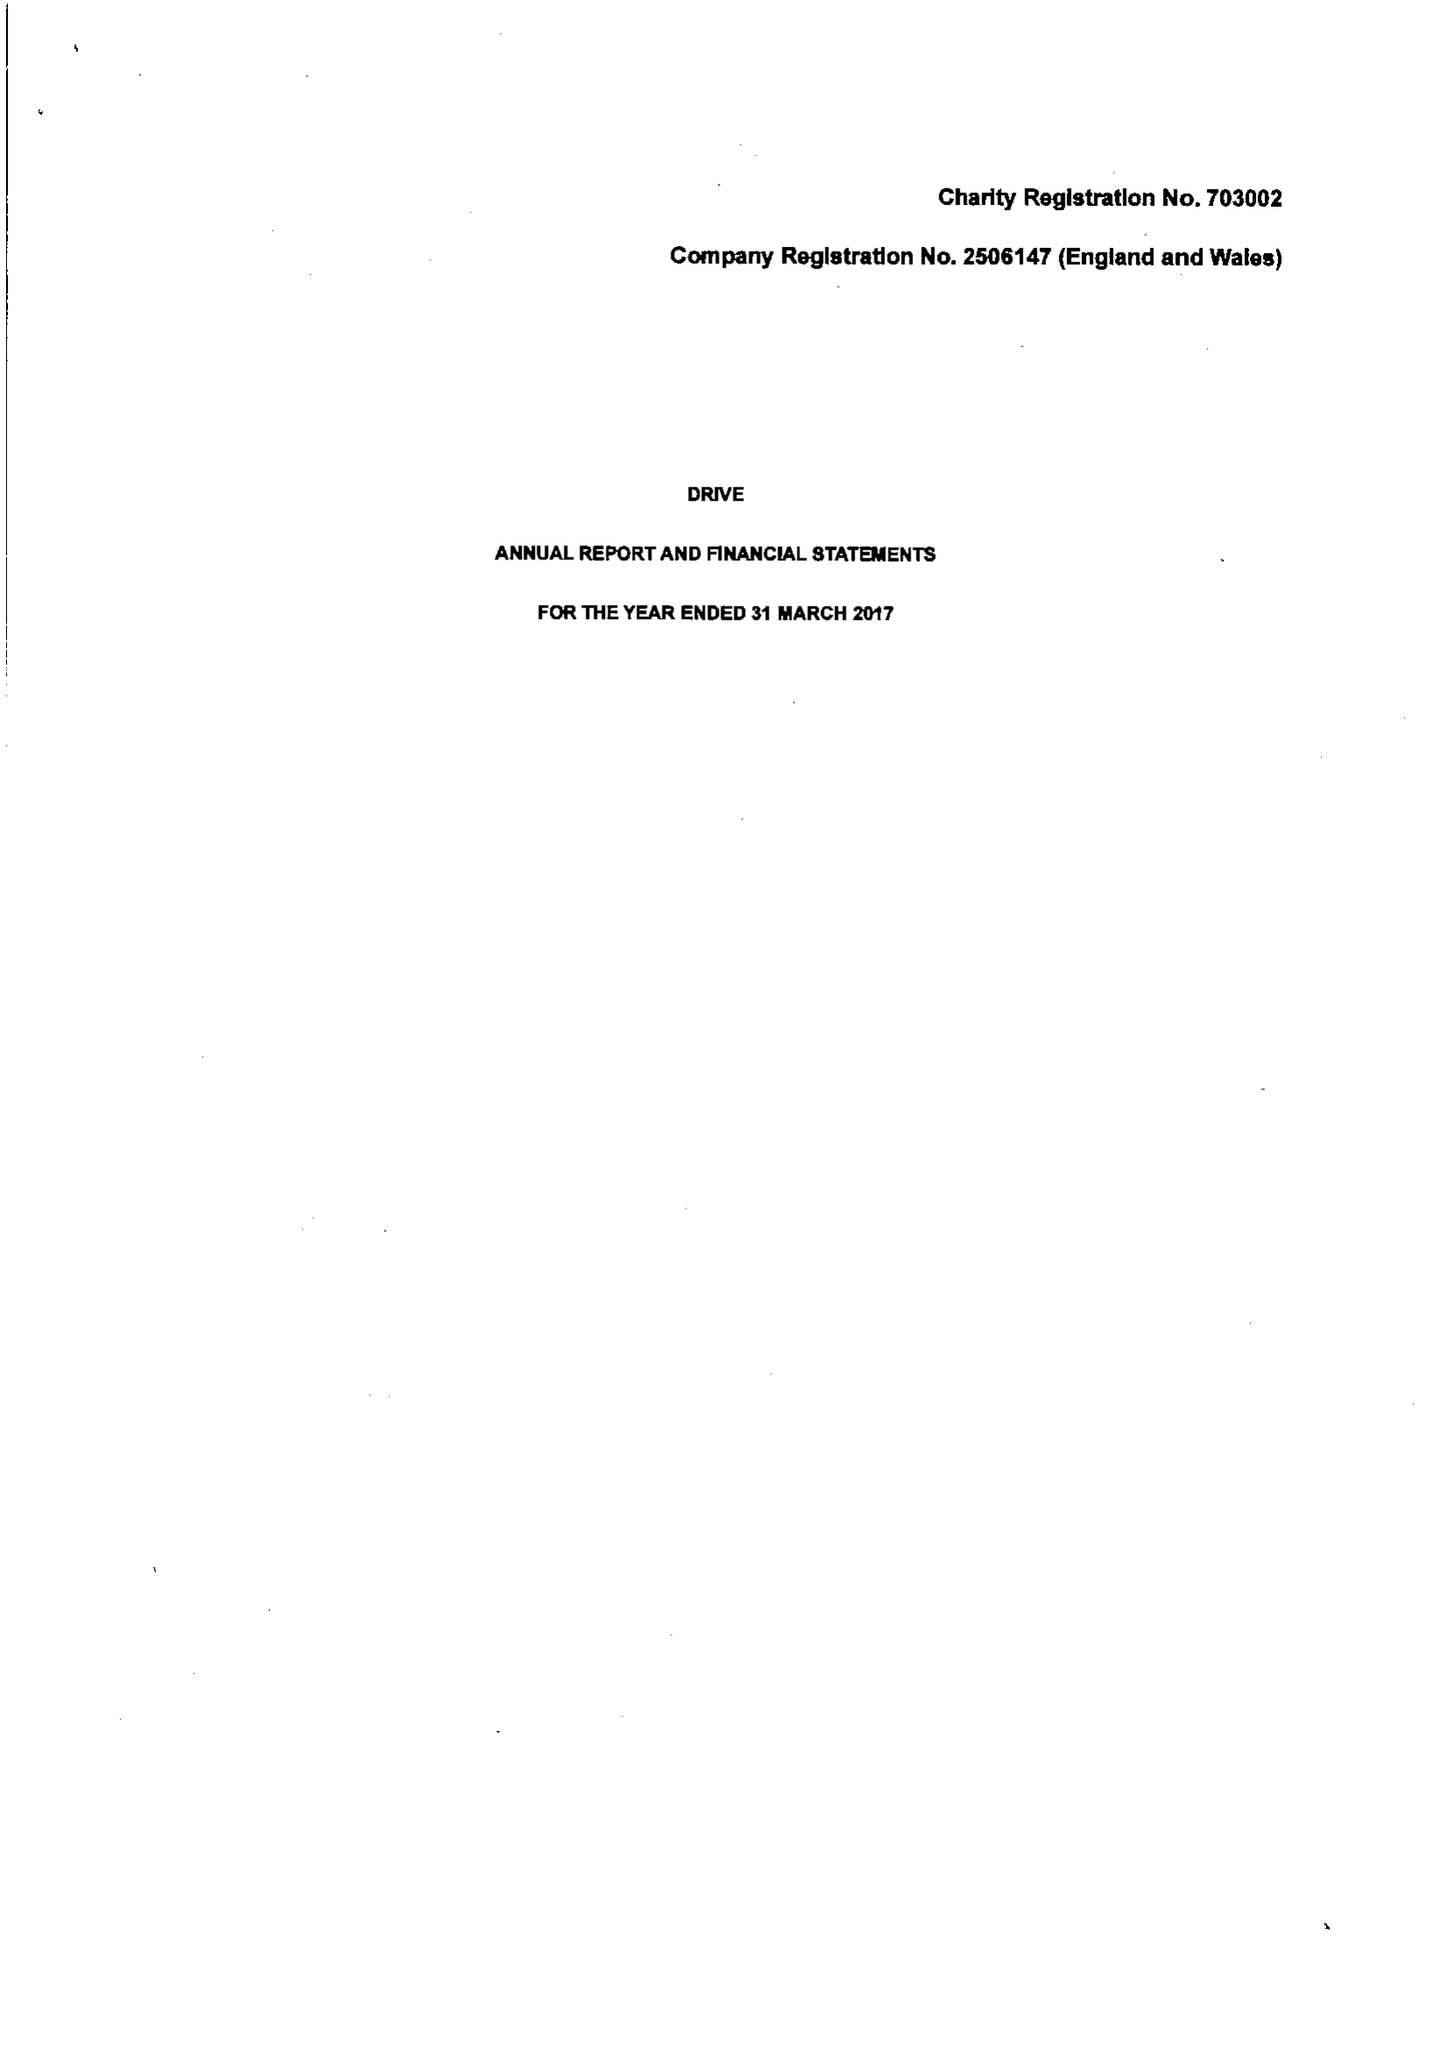What is the value for the report_date?
Answer the question using a single word or phrase. 2017-03-31 